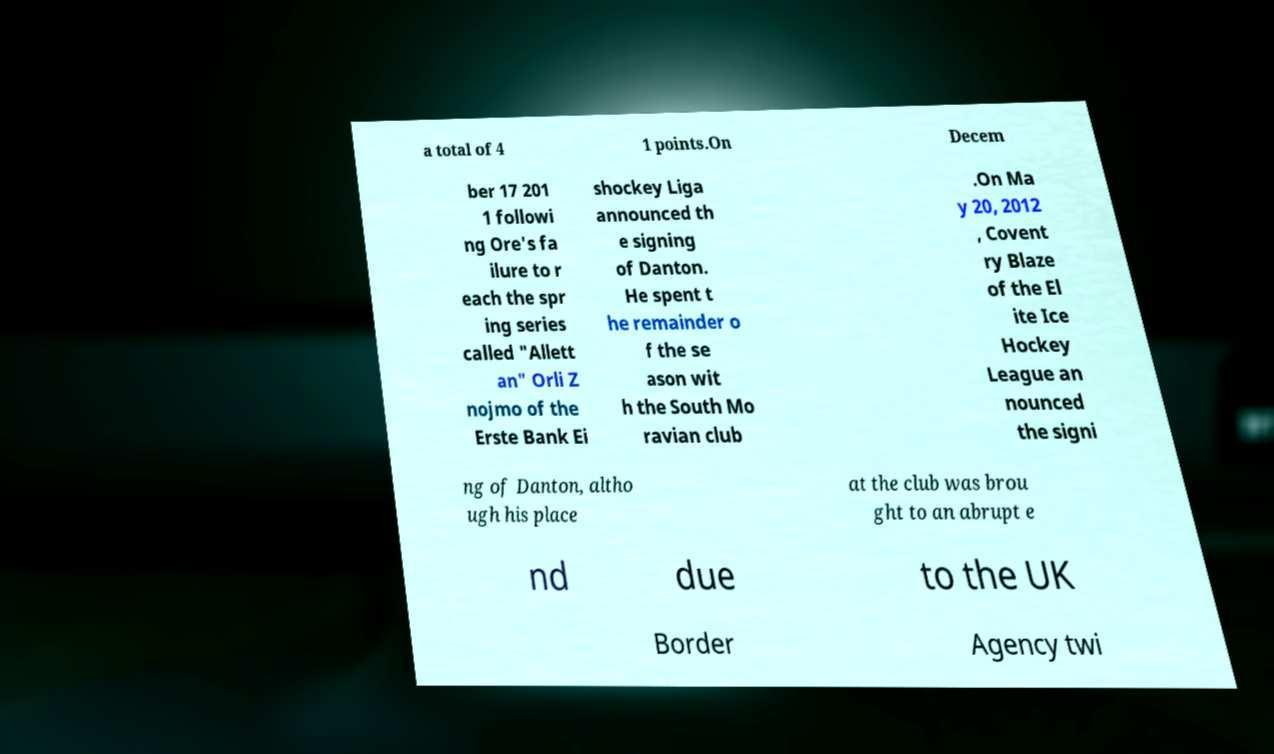Please identify and transcribe the text found in this image. a total of 4 1 points.On Decem ber 17 201 1 followi ng Ore's fa ilure to r each the spr ing series called "Allett an" Orli Z nojmo of the Erste Bank Ei shockey Liga announced th e signing of Danton. He spent t he remainder o f the se ason wit h the South Mo ravian club .On Ma y 20, 2012 , Covent ry Blaze of the El ite Ice Hockey League an nounced the signi ng of Danton, altho ugh his place at the club was brou ght to an abrupt e nd due to the UK Border Agency twi 